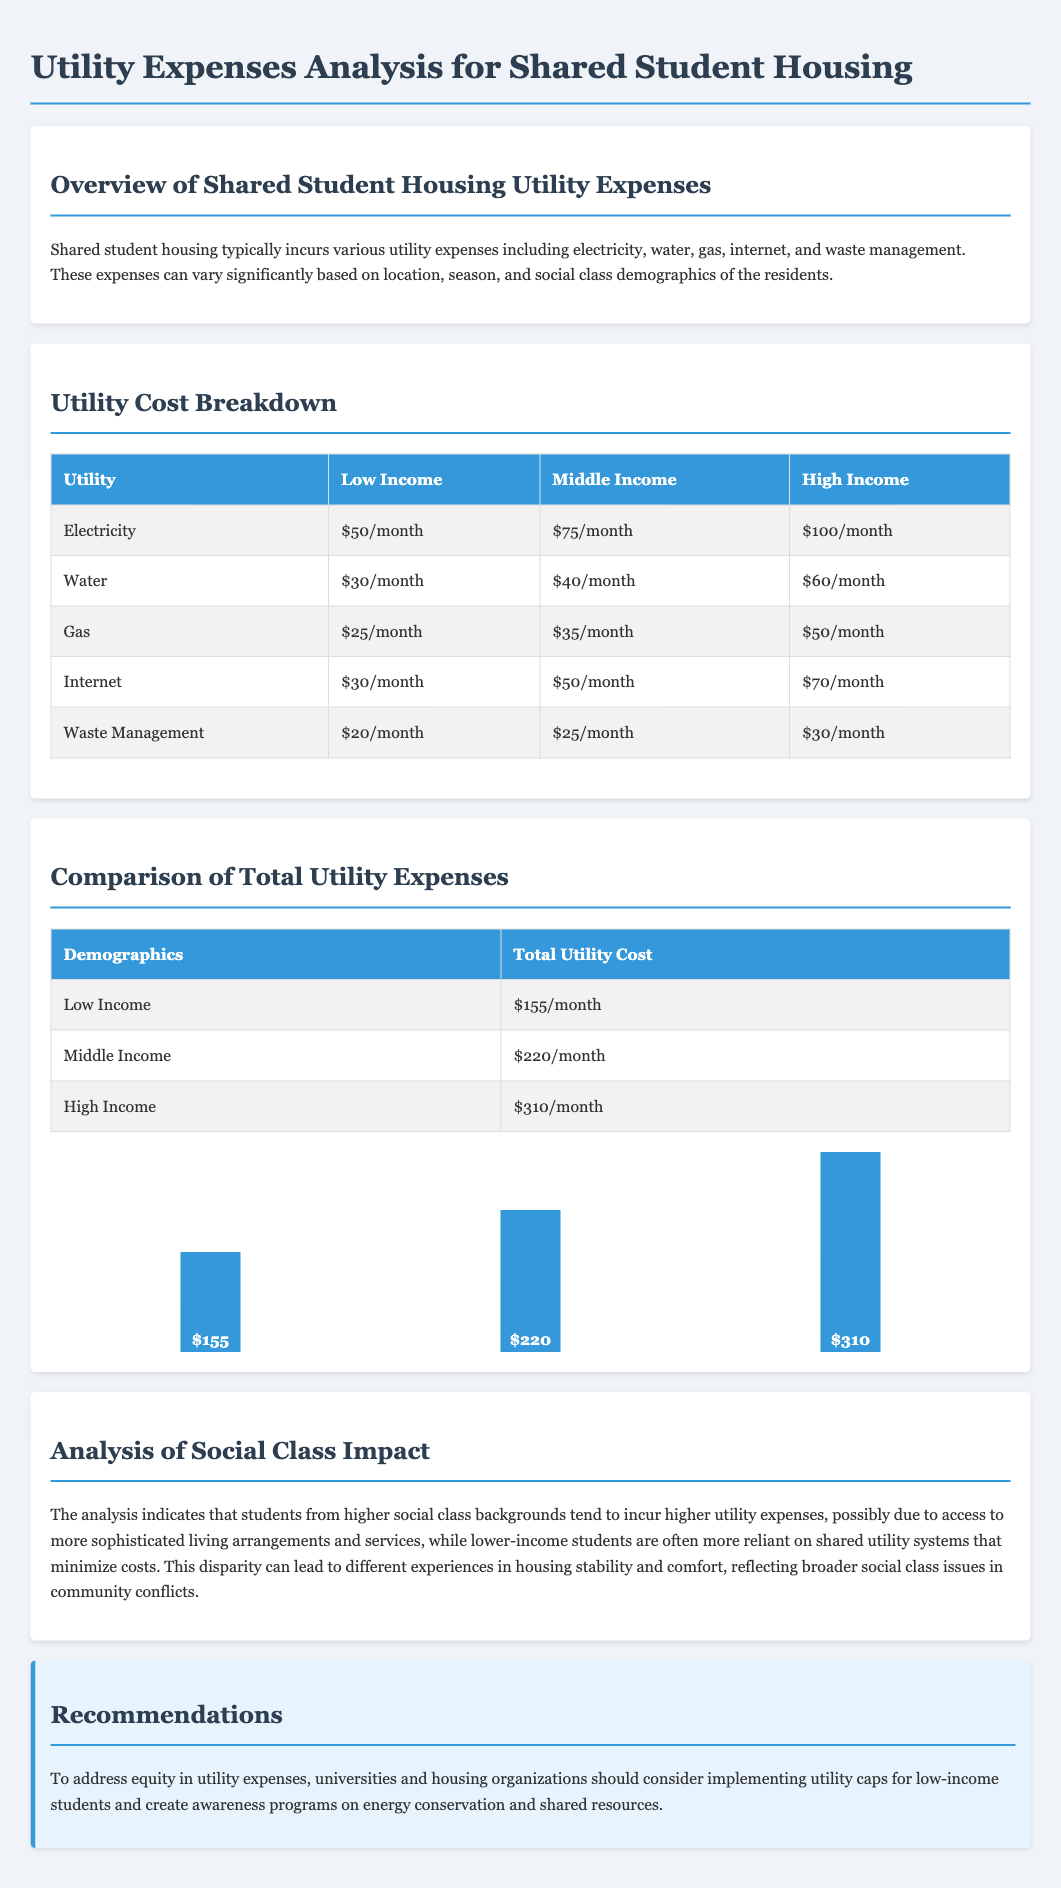What is the total utility cost for low-income students? The total utility cost for low-income students is listed in the document as $155/month.
Answer: $155/month What is the highest utility expense for high-income students? The highest utility expense for high-income students can be found by reviewing the utility cost breakdown table, showing $100/month for electricity.
Answer: $100/month How much do middle-income students pay for water? The document specifies that middle-income students pay $40/month for water.
Answer: $40/month What is the total utility cost for high-income students? The document calculates the total utility cost for high-income students to be $310/month.
Answer: $310/month Which utility has the lowest expense for low-income students? By examining the utility cost breakdown, the utility with the lowest expense for low-income students is waste management priced at $20/month.
Answer: Waste Management What does the analysis of social class impact suggest about utility expenses? The analysis suggests that higher social class students incur higher utility expenses due to access to more sophisticated living arrangements.
Answer: Higher expenses What recommendations are made to address equity in utility expenses? The recommendations section suggests implementing utility caps for low-income students and creating awareness programs.
Answer: Utility caps Which demographic has the highest total utility cost? The highest total utility cost demographic is high-income students, as listed in the document.
Answer: High Income What is the monthly gas expense for middle-income students? According to the utility cost breakdown, the monthly gas expense for middle-income students is $35.
Answer: $35 